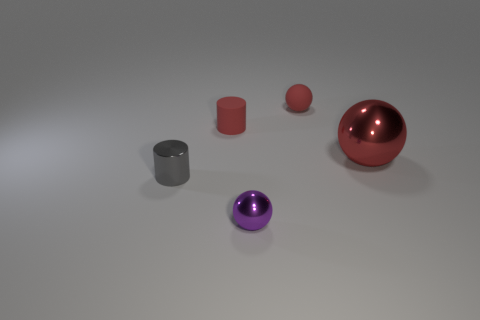Add 1 big spheres. How many objects exist? 6 Subtract all small red spheres. How many spheres are left? 2 Subtract all red balls. How many balls are left? 1 Subtract all spheres. How many objects are left? 2 Subtract all cyan blocks. How many gray cylinders are left? 1 Add 1 red cylinders. How many red cylinders are left? 2 Add 2 tiny gray shiny objects. How many tiny gray shiny objects exist? 3 Subtract 1 red cylinders. How many objects are left? 4 Subtract 2 cylinders. How many cylinders are left? 0 Subtract all purple spheres. Subtract all yellow cylinders. How many spheres are left? 2 